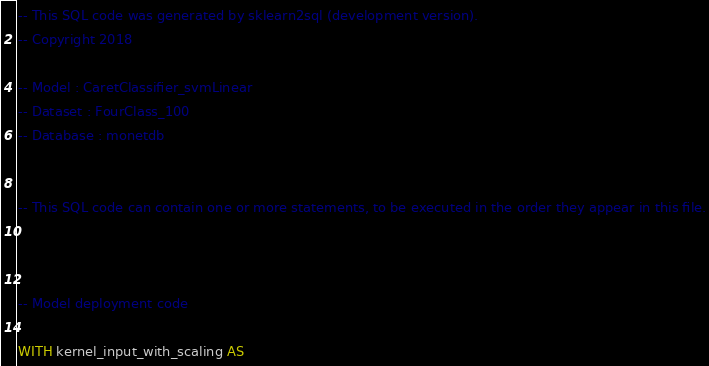<code> <loc_0><loc_0><loc_500><loc_500><_SQL_>-- This SQL code was generated by sklearn2sql (development version).
-- Copyright 2018

-- Model : CaretClassifier_svmLinear
-- Dataset : FourClass_100
-- Database : monetdb


-- This SQL code can contain one or more statements, to be executed in the order they appear in this file.



-- Model deployment code

WITH kernel_input_with_scaling AS </code> 